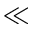Convert formula to latex. <formula><loc_0><loc_0><loc_500><loc_500>\ll</formula> 